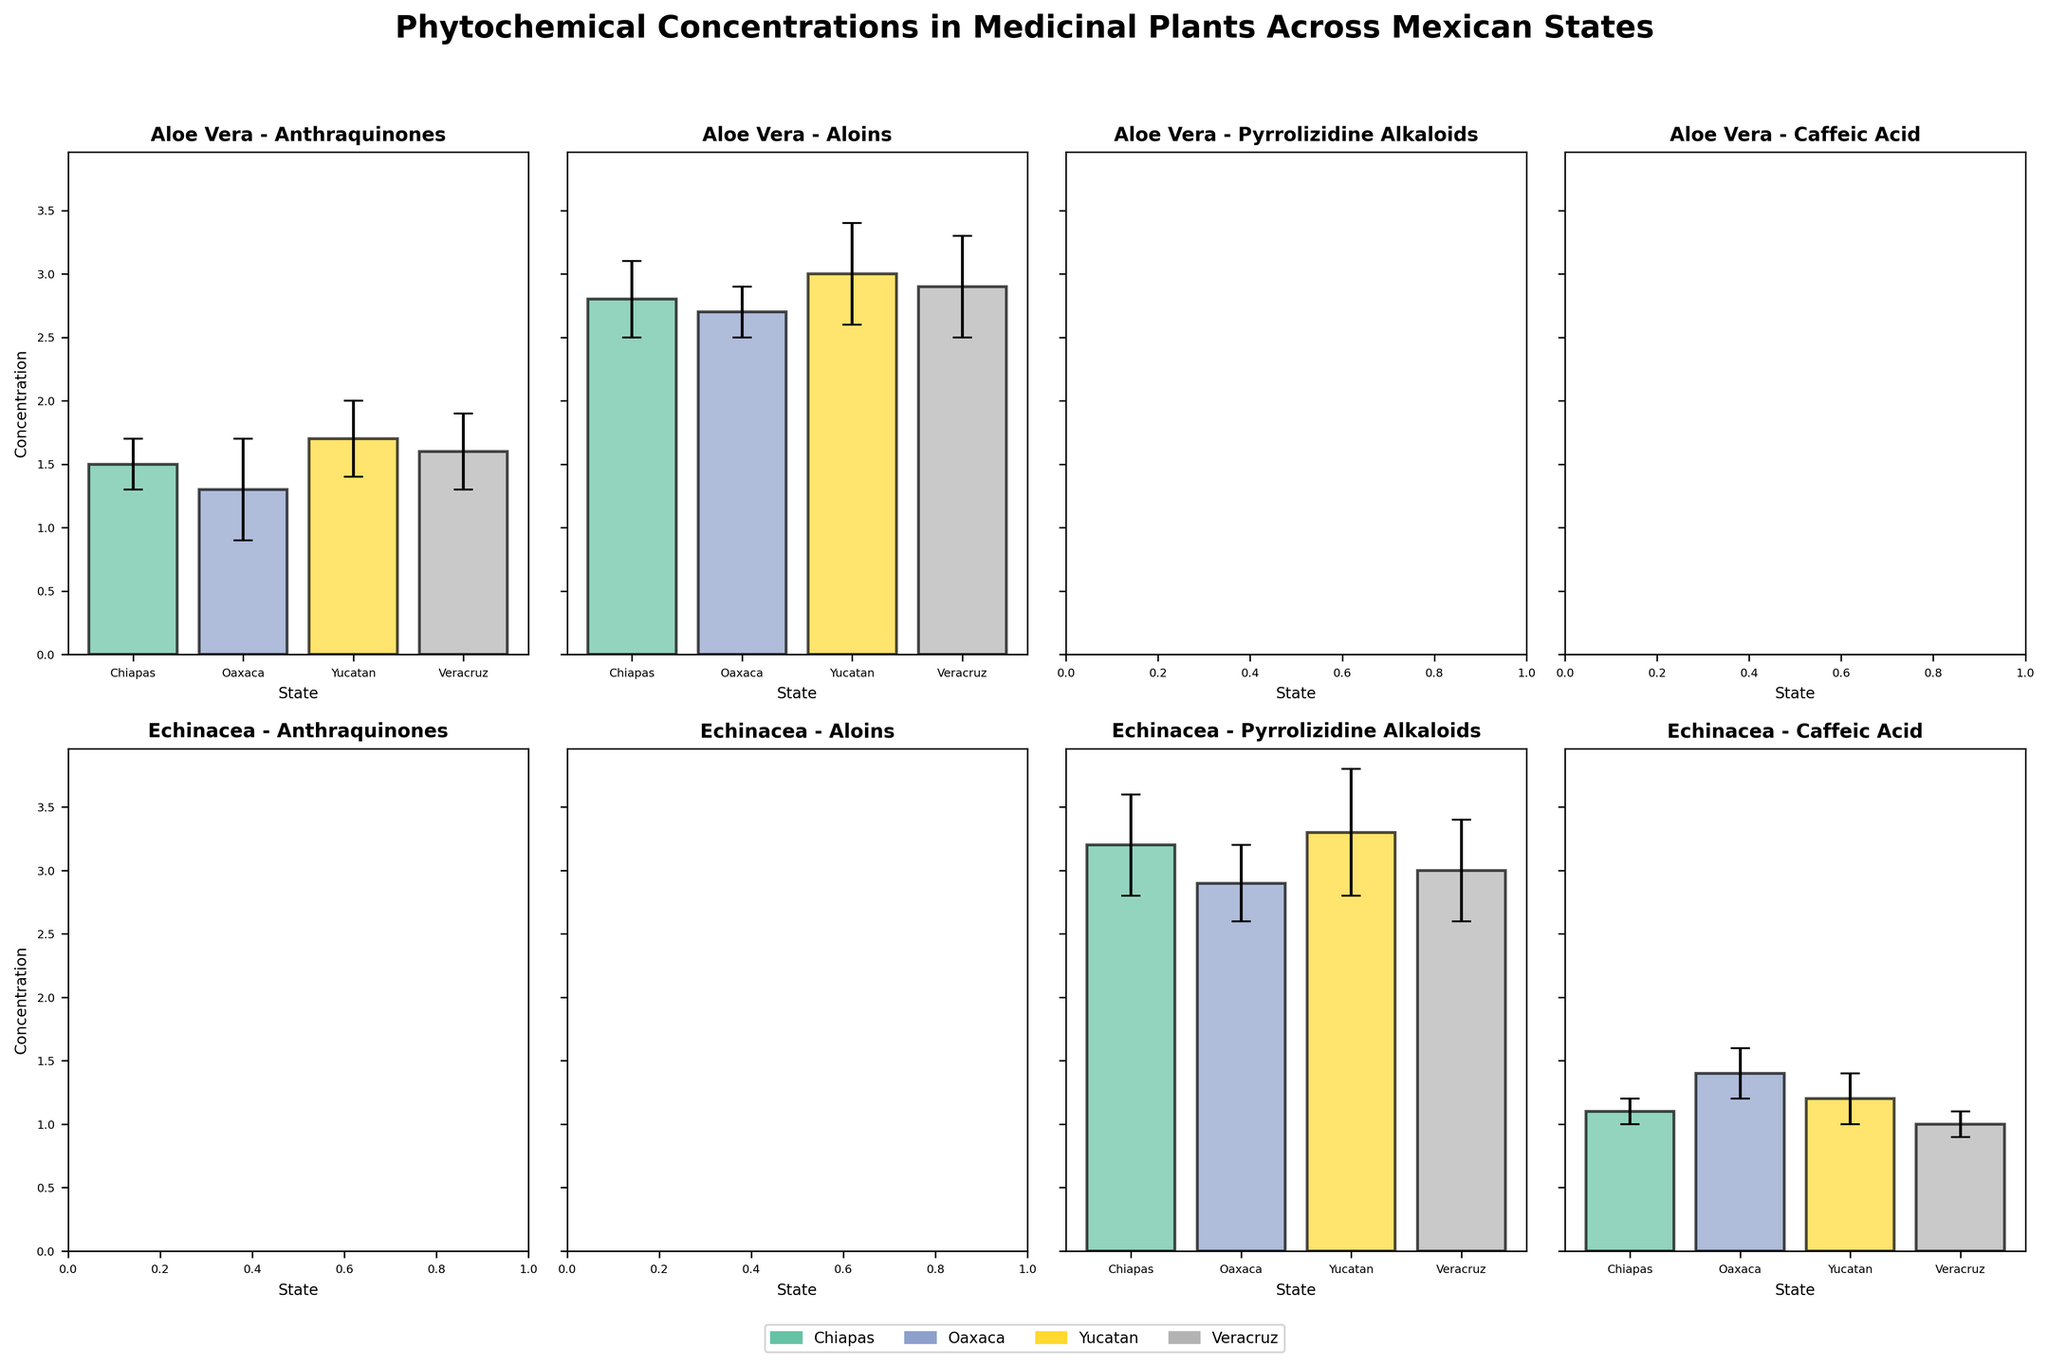How many states are being compared in the figure? There are Chiapas, Oaxaca, Yucatan, and Veracruz. The figure has bars for each of these states.
Answer: Four Which plant in Yucatan has the highest concentration of Aloins? By looking at the subplot for Yucatan and the phytochemical Aloins, you can see which plant has the highest bar. Aloe Vera has the highest concentration.
Answer: Aloe Vera What is the average concentration of Pyrrolizidine Alkaloids in Echinacea across all states? Identify the concentration values for Pyrrolizidine Alkaloids in Echinacea in Chiapas (3.2), Oaxaca (2.9), Yucatan (3.3), and Veracruz (3.0). Sum these values and divide by 4: (3.2 + 2.9 + 3.3 + 3.0) / 4 = 3.1
Answer: 3.1 Which state has the highest concentration of Anthraquinones in Aloe Vera? Look at the bar heights in the Anthraquinones plot for Aloe Vera across Chiapas, Oaxaca, Yucatan, and Veracruz. The tallest bar indicates the highest concentration. Yucatan has the tallest bar.
Answer: Yucatan What is the difference in concentration of Caffeic Acid in Echinacea between Chiapas and Veracruz? Identify the concentration values for Caffeic Acid in Echinacea in Chiapas (1.1) and Veracruz (1.0). Subtract the Veracruz value from the Chiapas value: 1.1 - 1.0 = 0.1
Answer: 0.1 Which state has the smallest standard deviation for any phytochemical in Aloe Vera? Check the error bars in the Aloe Vera subplots. The shortest error bar represents the smallest standard deviation. For Aloe Vera, the state Oaxaca for Aloins has a standard deviation of 0.2, which is the smallest.
Answer: Oaxaca (for Aloins) Is the concentration of Caffeic Acid in Echinacea higher in Oaxaca or Yucatan? Compare the heights of the bars in the Caffeic Acid subplot for Echinacea in Oaxaca and Yucatan. Oaxaca's bar (1.4) is higher than Yucatan's bar (1.2).
Answer: Oaxaca 